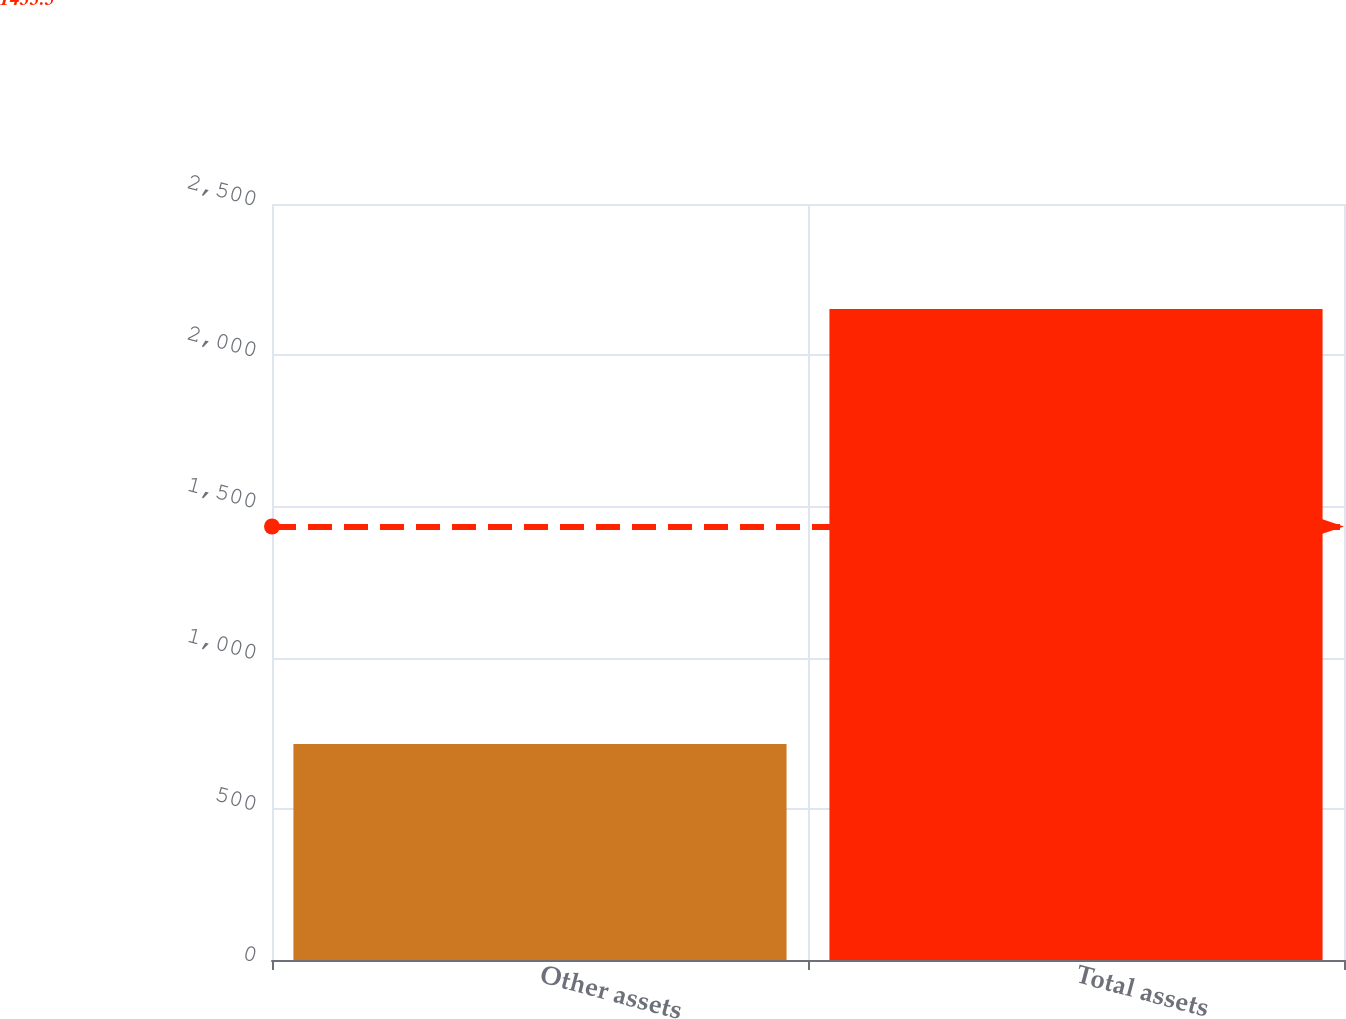<chart> <loc_0><loc_0><loc_500><loc_500><bar_chart><fcel>Other assets<fcel>Total assets<nl><fcel>714<fcel>2153<nl></chart> 